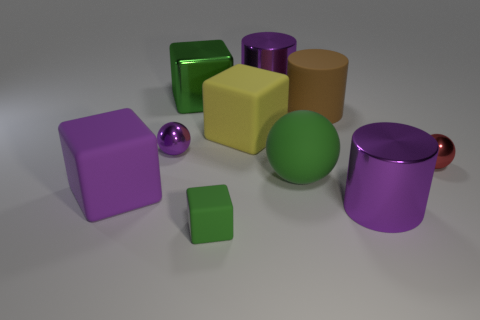Subtract 1 blocks. How many blocks are left? 3 Subtract all cylinders. How many objects are left? 7 Add 4 big matte things. How many big matte things exist? 8 Subtract 0 yellow cylinders. How many objects are left? 10 Subtract all small cyan metal spheres. Subtract all small rubber objects. How many objects are left? 9 Add 1 metallic things. How many metallic things are left? 6 